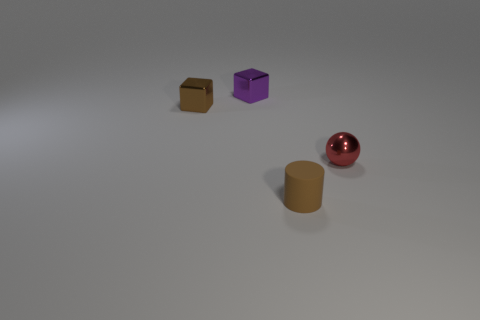Are any large balls visible?
Provide a short and direct response. No. What is the object that is both right of the brown shiny thing and behind the small red metal object made of?
Ensure brevity in your answer.  Metal. Are there more brown cylinders on the right side of the red object than small metal spheres that are in front of the brown cube?
Your answer should be very brief. No. Is there a brown cylinder of the same size as the red metal thing?
Provide a short and direct response. Yes. There is a shiny cube in front of the metallic thing behind the small brown thing that is to the left of the cylinder; how big is it?
Offer a very short reply. Small. The sphere has what color?
Make the answer very short. Red. Are there more tiny matte things behind the small rubber thing than small matte cylinders?
Offer a very short reply. No. How many brown matte objects are in front of the small brown metallic thing?
Make the answer very short. 1. What shape is the metallic object that is the same color as the cylinder?
Your answer should be compact. Cube. There is a small shiny object right of the small brown cylinder to the left of the tiny sphere; are there any brown metal things in front of it?
Your response must be concise. No. 